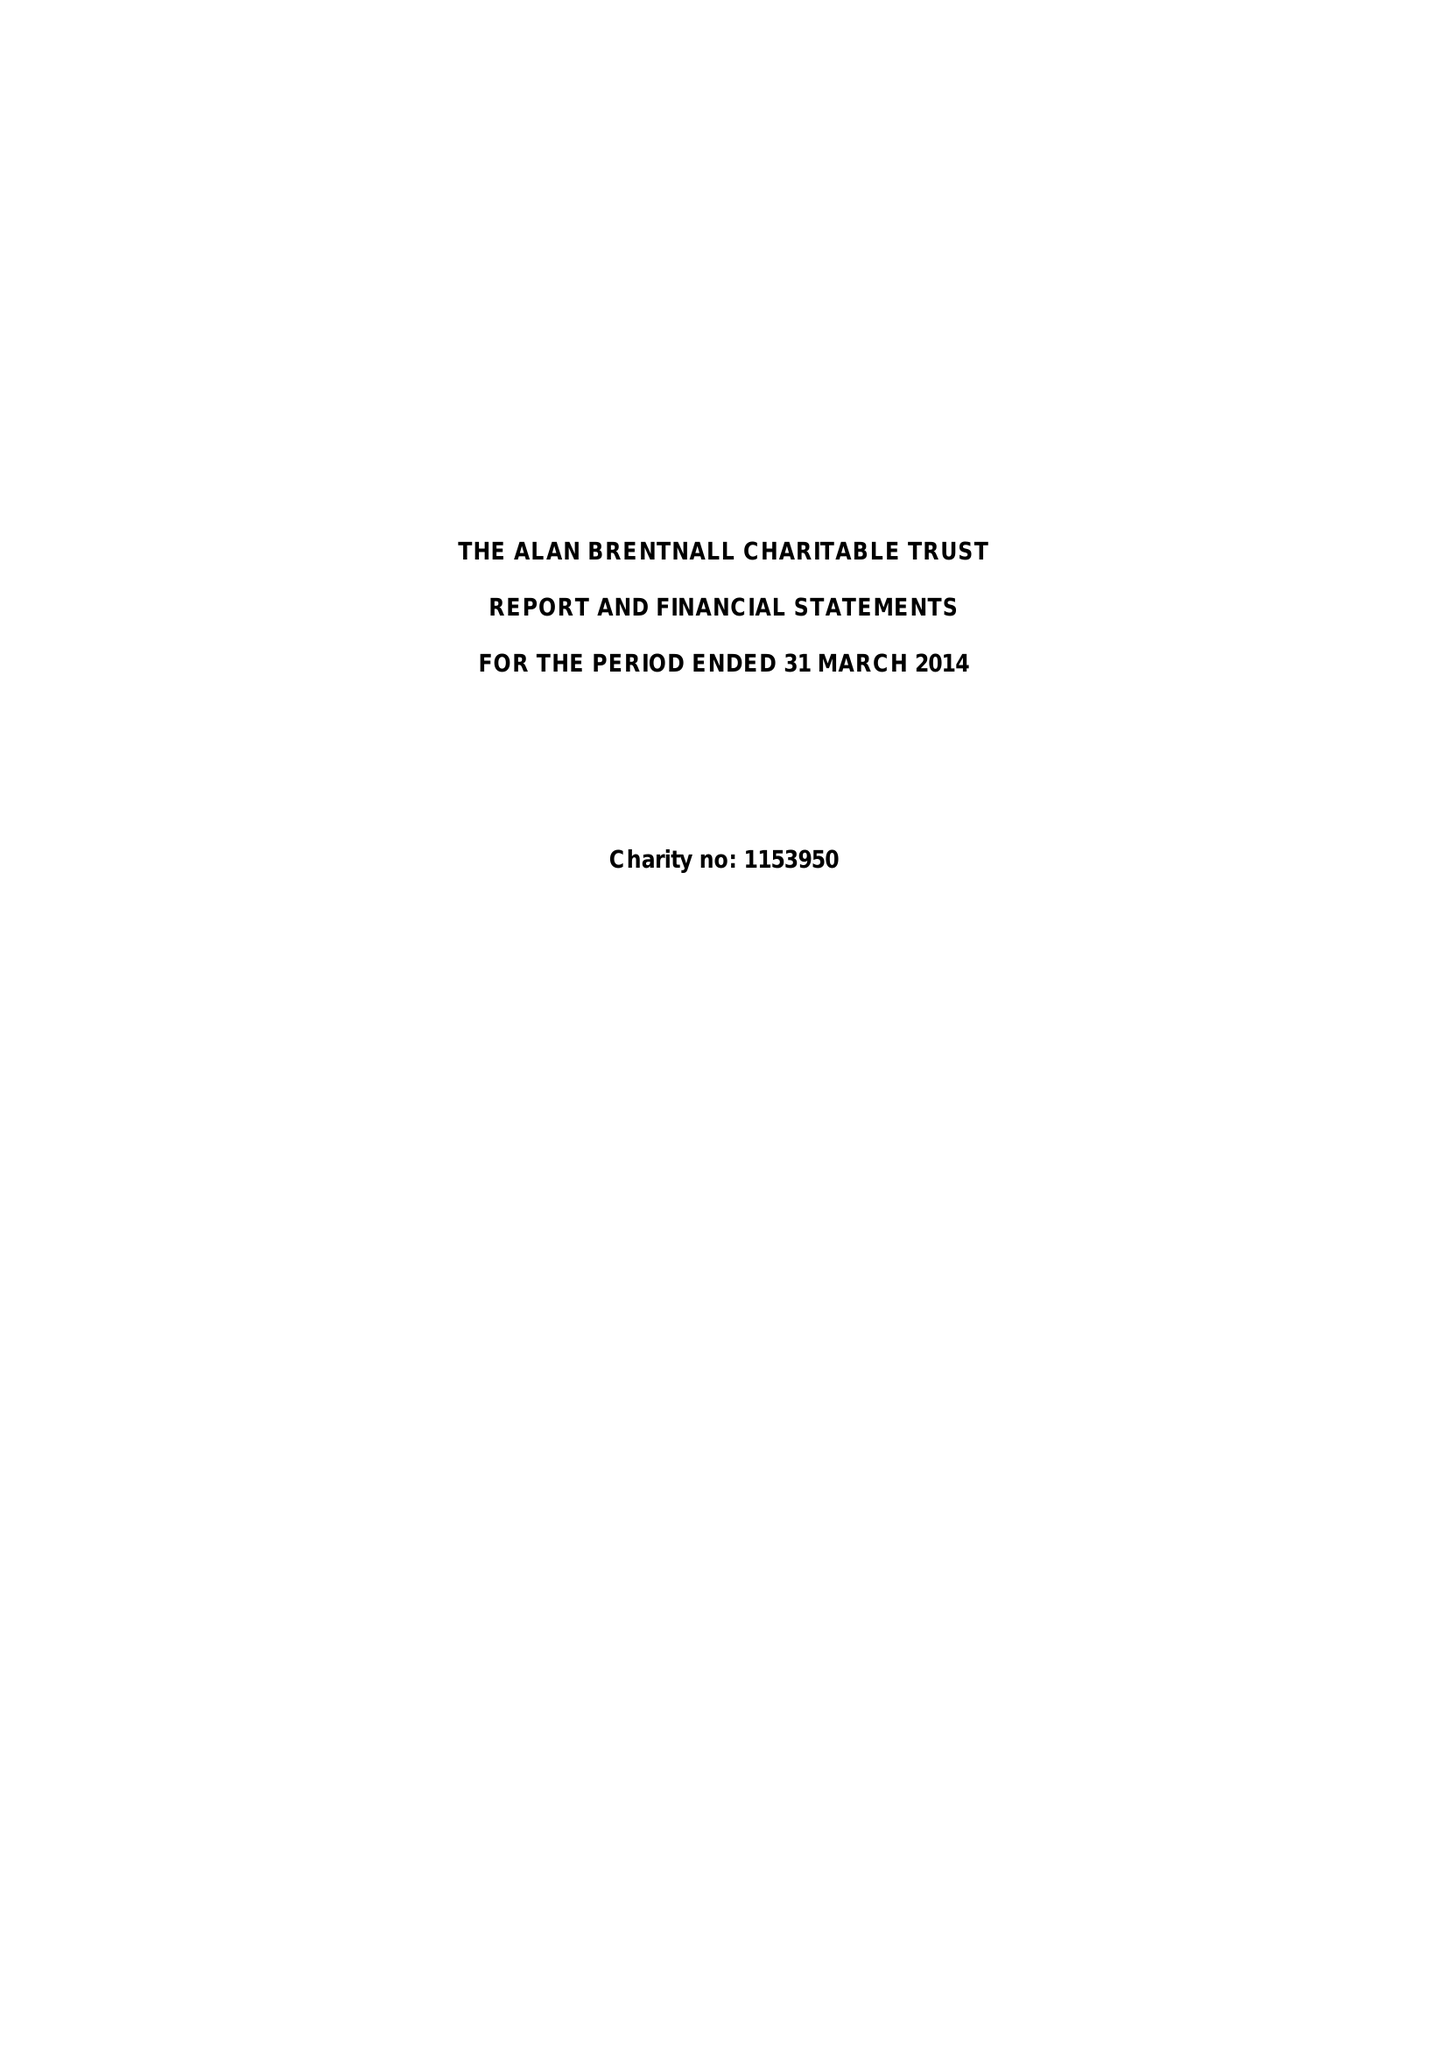What is the value for the income_annually_in_british_pounds?
Answer the question using a single word or phrase. 1500195.00 